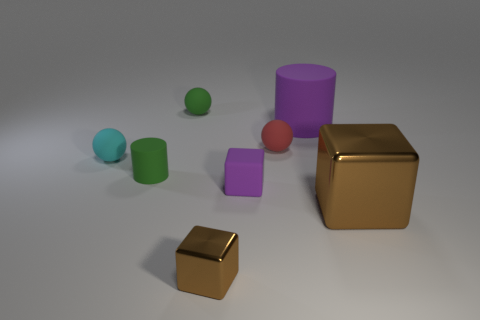Do the small brown block and the large brown block have the same material?
Keep it short and to the point. Yes. How many other objects are there of the same size as the purple block?
Your answer should be compact. 5. The block to the right of the rubber cylinder behind the small red thing is what color?
Your response must be concise. Brown. What number of other objects are there of the same shape as the large matte thing?
Your answer should be compact. 1. Is there a green cylinder that has the same material as the cyan object?
Ensure brevity in your answer.  Yes. What is the material of the purple block that is the same size as the red ball?
Provide a succinct answer. Rubber. There is a cylinder behind the tiny rubber object on the right side of the tiny cube that is behind the tiny brown cube; what color is it?
Keep it short and to the point. Purple. Do the brown metal object that is to the right of the tiny shiny block and the small green thing in front of the green sphere have the same shape?
Keep it short and to the point. No. How many red balls are there?
Keep it short and to the point. 1. What color is the matte cylinder that is the same size as the red rubber object?
Your answer should be compact. Green. 